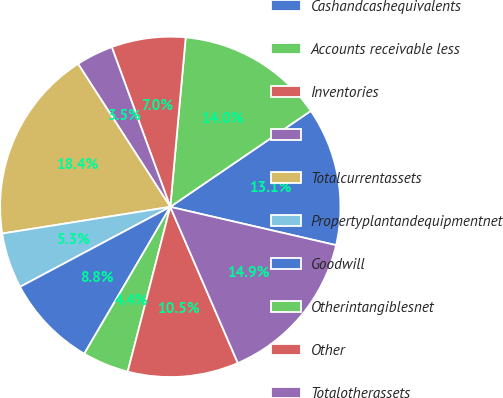<chart> <loc_0><loc_0><loc_500><loc_500><pie_chart><fcel>Cashandcashequivalents<fcel>Accounts receivable less<fcel>Inventories<fcel>Unnamed: 3<fcel>Totalcurrentassets<fcel>Propertyplantandequipmentnet<fcel>Goodwill<fcel>Otherintangiblesnet<fcel>Other<fcel>Totalotherassets<nl><fcel>13.15%<fcel>14.02%<fcel>7.03%<fcel>3.53%<fcel>18.39%<fcel>5.28%<fcel>8.78%<fcel>4.41%<fcel>10.52%<fcel>14.89%<nl></chart> 